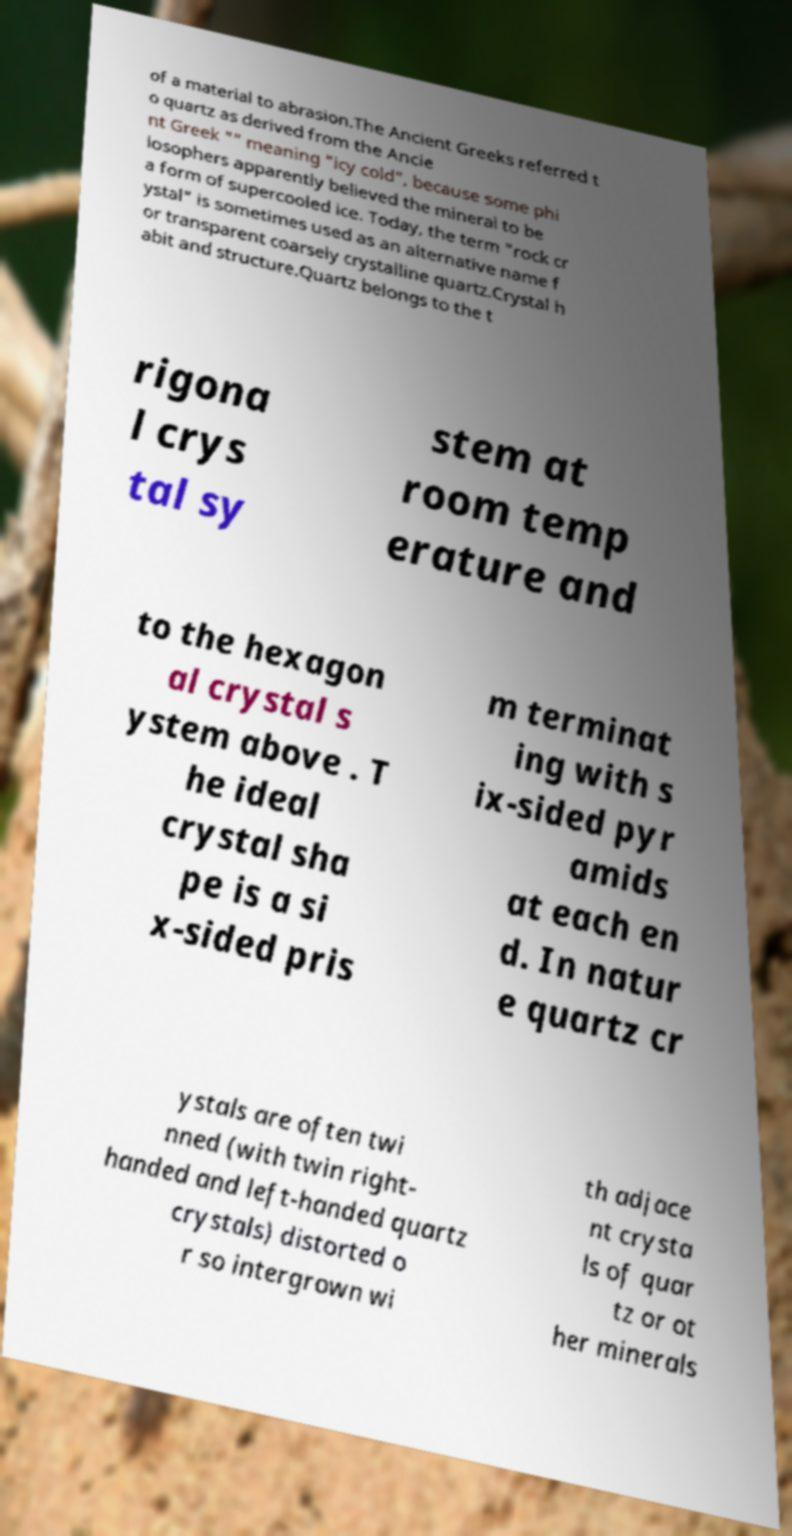Please identify and transcribe the text found in this image. of a material to abrasion.The Ancient Greeks referred t o quartz as derived from the Ancie nt Greek "" meaning "icy cold", because some phi losophers apparently believed the mineral to be a form of supercooled ice. Today, the term "rock cr ystal" is sometimes used as an alternative name f or transparent coarsely crystalline quartz.Crystal h abit and structure.Quartz belongs to the t rigona l crys tal sy stem at room temp erature and to the hexagon al crystal s ystem above . T he ideal crystal sha pe is a si x-sided pris m terminat ing with s ix-sided pyr amids at each en d. In natur e quartz cr ystals are often twi nned (with twin right- handed and left-handed quartz crystals) distorted o r so intergrown wi th adjace nt crysta ls of quar tz or ot her minerals 